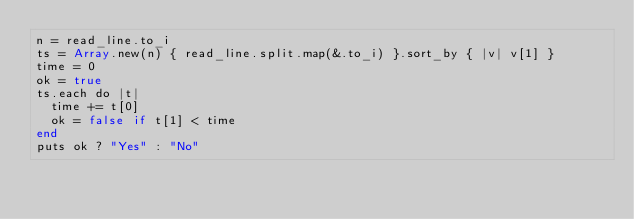Convert code to text. <code><loc_0><loc_0><loc_500><loc_500><_Crystal_>n = read_line.to_i
ts = Array.new(n) { read_line.split.map(&.to_i) }.sort_by { |v| v[1] }
time = 0
ok = true
ts.each do |t|
  time += t[0]
  ok = false if t[1] < time
end
puts ok ? "Yes" : "No"
</code> 